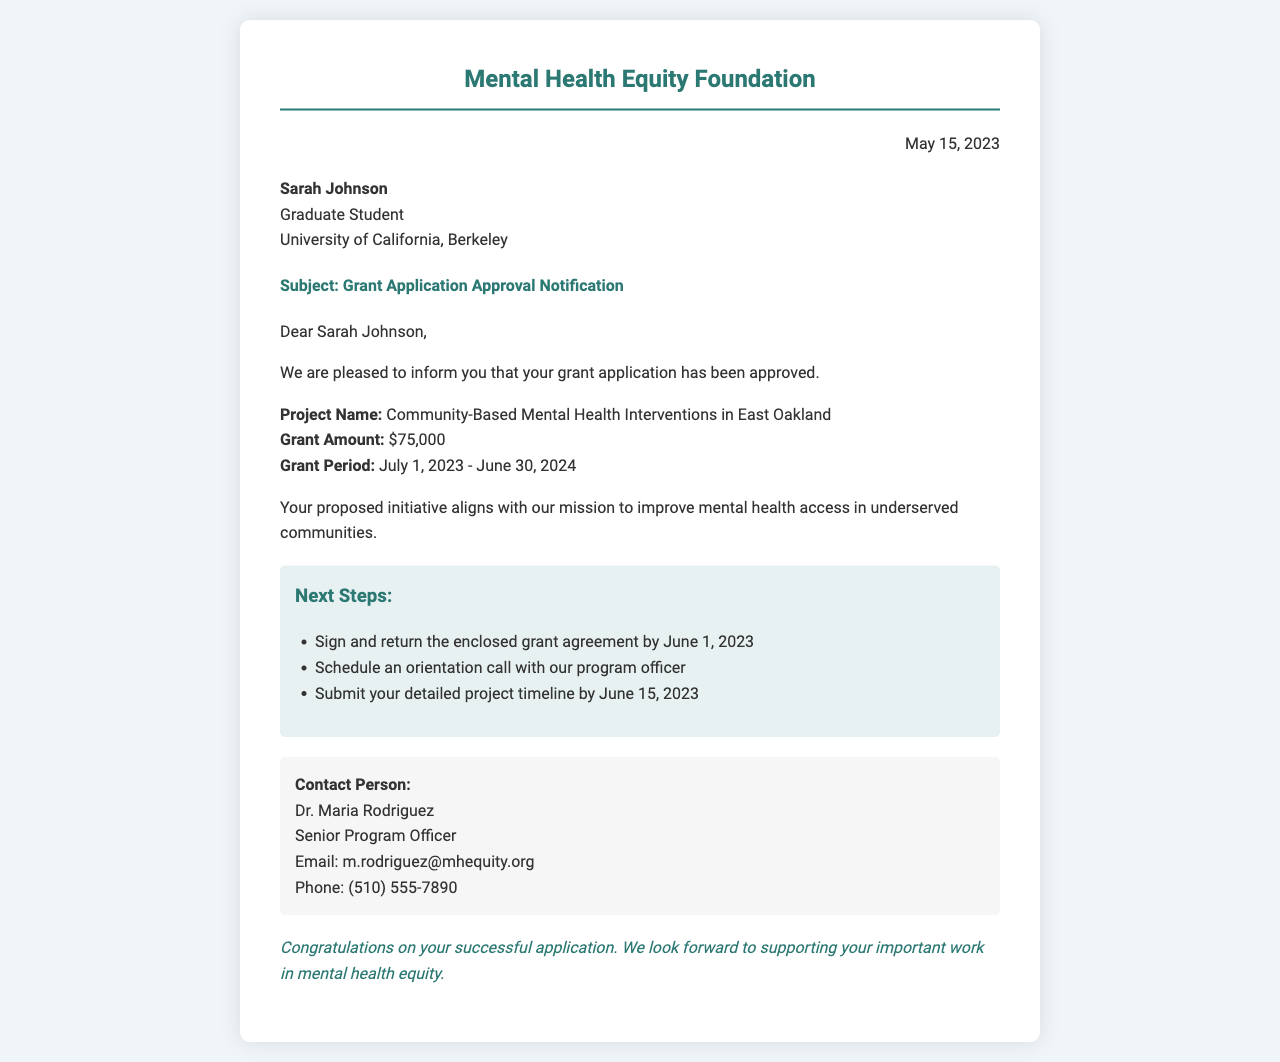What is the name of the recipient? The recipient's name is stated in the document as "Sarah Johnson."
Answer: Sarah Johnson What is the grant amount awarded? The document explicitly mentions the grant amount as "$75,000."
Answer: $75,000 What is the grant period? The grant period is indicated as "July 1, 2023 - June 30, 2024."
Answer: July 1, 2023 - June 30, 2024 Who is the contact person for this grant? The document lists the contact person as "Dr. Maria Rodriguez."
Answer: Dr. Maria Rodriguez What is the title of the project? The title of the project is mentioned as "Community-Based Mental Health Interventions in East Oakland."
Answer: Community-Based Mental Health Interventions in East Oakland By what date should the grant agreement be signed and returned? The document specifies that the grant agreement must be returned by "June 1, 2023."
Answer: June 1, 2023 What organization is issuing the grant? The organization that issued the grant is the "Mental Health Equity Foundation."
Answer: Mental Health Equity Foundation What is the purpose of the initiative? The purpose of the initiative is to "improve mental health access in underserved communities."
Answer: improve mental health access in underserved communities What is one of the next steps after receiving the approval? The document lists "Schedule an orientation call with our program officer" as a next step.
Answer: Schedule an orientation call with our program officer 